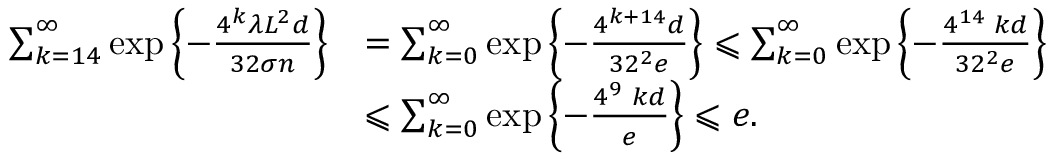<formula> <loc_0><loc_0><loc_500><loc_500>\begin{array} { r l } { \sum _ { k = 1 4 } ^ { \infty } \exp \left \{ - \frac { 4 ^ { k } \lambda L ^ { 2 } d } { 3 2 \sigma n } \right \} } & { = \sum _ { k = 0 } ^ { \infty } \exp \left \{ - \frac { 4 ^ { k + 1 4 } d } { 3 2 ^ { 2 } e } \right \} \leqslant \sum _ { k = 0 } ^ { \infty } \exp \left \{ - \frac { 4 ^ { 1 4 } \, k d } { 3 2 ^ { 2 } e } \right \} } \\ & { \leqslant \sum _ { k = 0 } ^ { \infty } \exp \left \{ - \frac { 4 ^ { 9 } \, k d } { e } \right \} \leqslant e . } \end{array}</formula> 